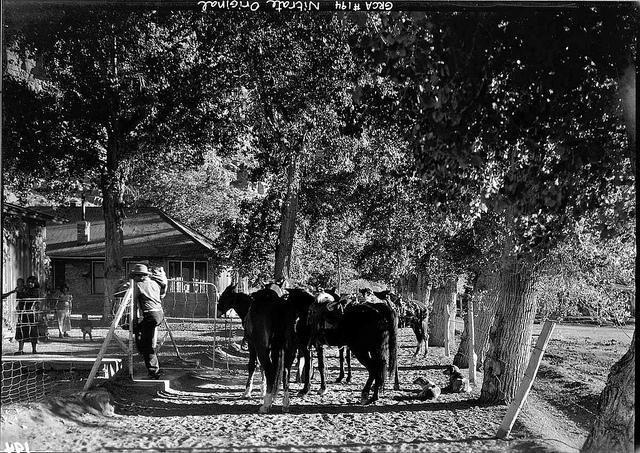How many horses are pictured?
Give a very brief answer. 3. How many people can you see?
Give a very brief answer. 1. How many horses are there?
Give a very brief answer. 2. How many cows in this photo?
Give a very brief answer. 0. 